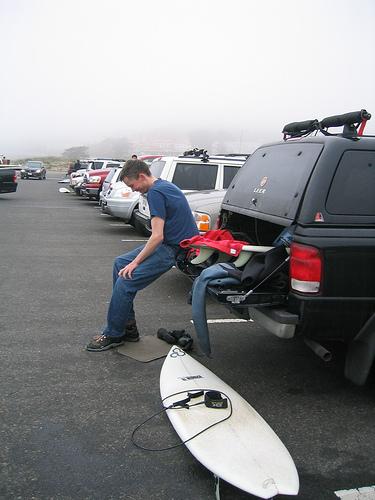What is on top of the black vehicle?
Give a very brief answer. Rack. Does this person look like he is in pain?
Quick response, please. Yes. What is laying on the ground?
Keep it brief. Surfboard. 